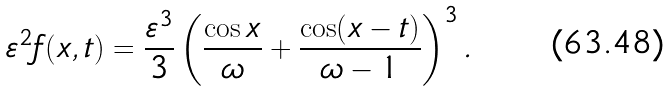Convert formula to latex. <formula><loc_0><loc_0><loc_500><loc_500>\varepsilon ^ { 2 } f ( x , t ) = \frac { \varepsilon ^ { 3 } } { 3 } \left ( \frac { \cos x } { \omega } + \frac { \cos ( x - t ) } { \omega - 1 } \right ) ^ { 3 } .</formula> 